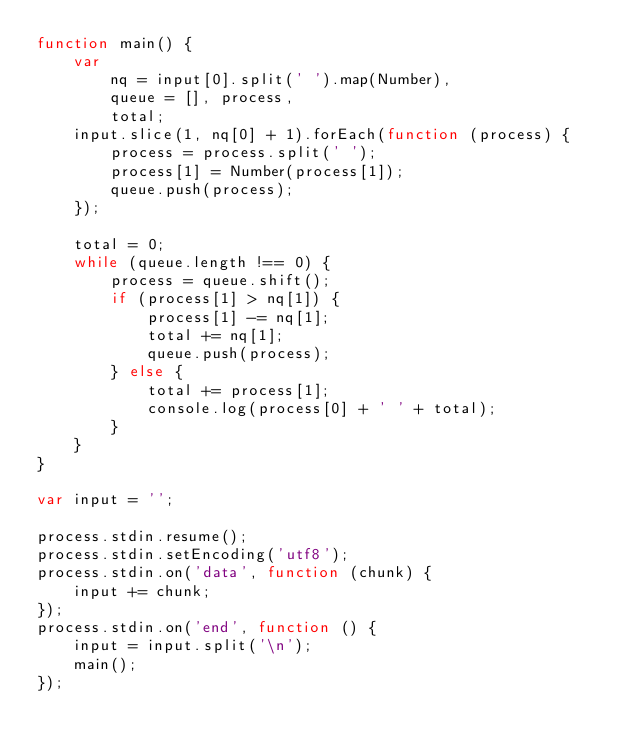<code> <loc_0><loc_0><loc_500><loc_500><_JavaScript_>function main() {
    var
        nq = input[0].split(' ').map(Number),
        queue = [], process,
        total;
    input.slice(1, nq[0] + 1).forEach(function (process) {
        process = process.split(' ');
        process[1] = Number(process[1]);
        queue.push(process);
    });

    total = 0;
    while (queue.length !== 0) {
        process = queue.shift();
        if (process[1] > nq[1]) {
            process[1] -= nq[1];
            total += nq[1];
            queue.push(process);
        } else {
            total += process[1];
            console.log(process[0] + ' ' + total);
        }
    }
}

var input = '';

process.stdin.resume();
process.stdin.setEncoding('utf8');
process.stdin.on('data', function (chunk) {
    input += chunk;
});
process.stdin.on('end', function () {
    input = input.split('\n');
    main();
});</code> 